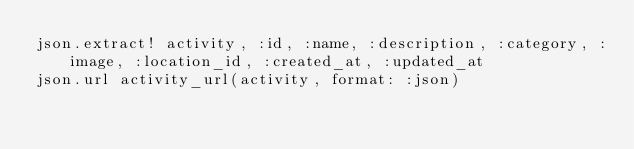<code> <loc_0><loc_0><loc_500><loc_500><_Ruby_>json.extract! activity, :id, :name, :description, :category, :image, :location_id, :created_at, :updated_at
json.url activity_url(activity, format: :json)
</code> 